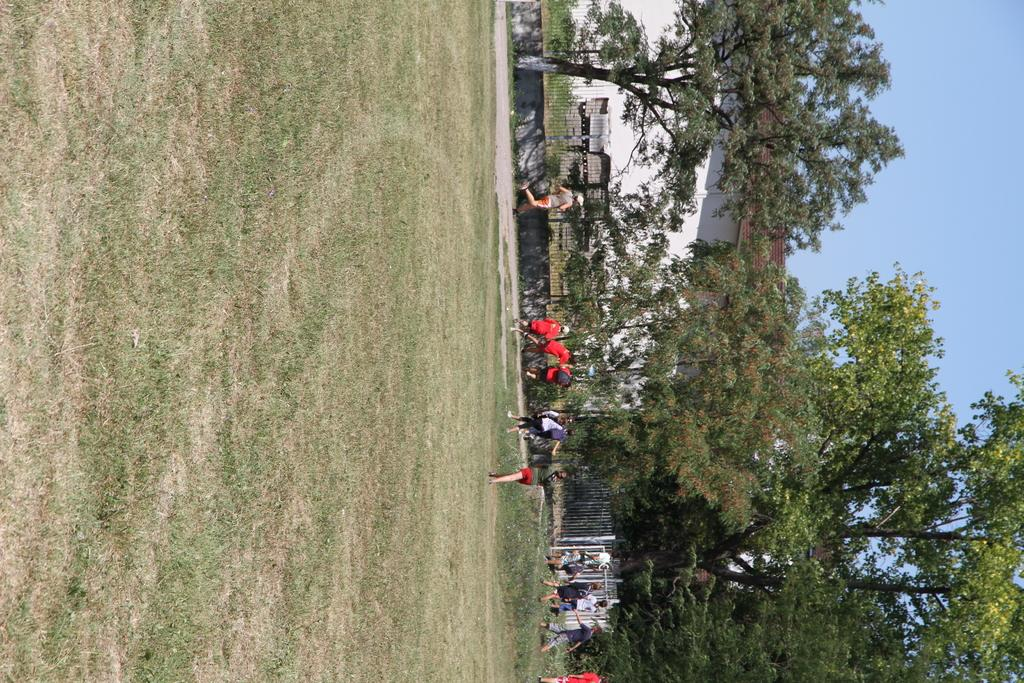How many people are in the image? There is a group of people in the image. What are some of the people doing in the image? Some people are walking, and some people are running. What can be seen in the background of the image? There is a fence, trees, and a house in the background of the image. What type of snail can be seen walking alongside the people in the image? There is no snail present in the image; it only features a group of people walking and running. Can you tell me the name of the dad in the image? There is no specific person identified as a dad in the image, as it only shows a group of people. 